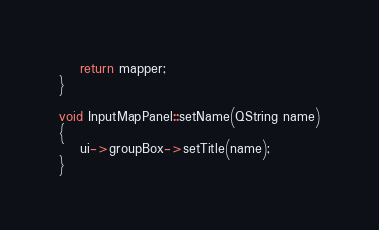Convert code to text. <code><loc_0><loc_0><loc_500><loc_500><_C++_>    return mapper;
}

void InputMapPanel::setName(QString name)
{
    ui->groupBox->setTitle(name);
}
</code> 